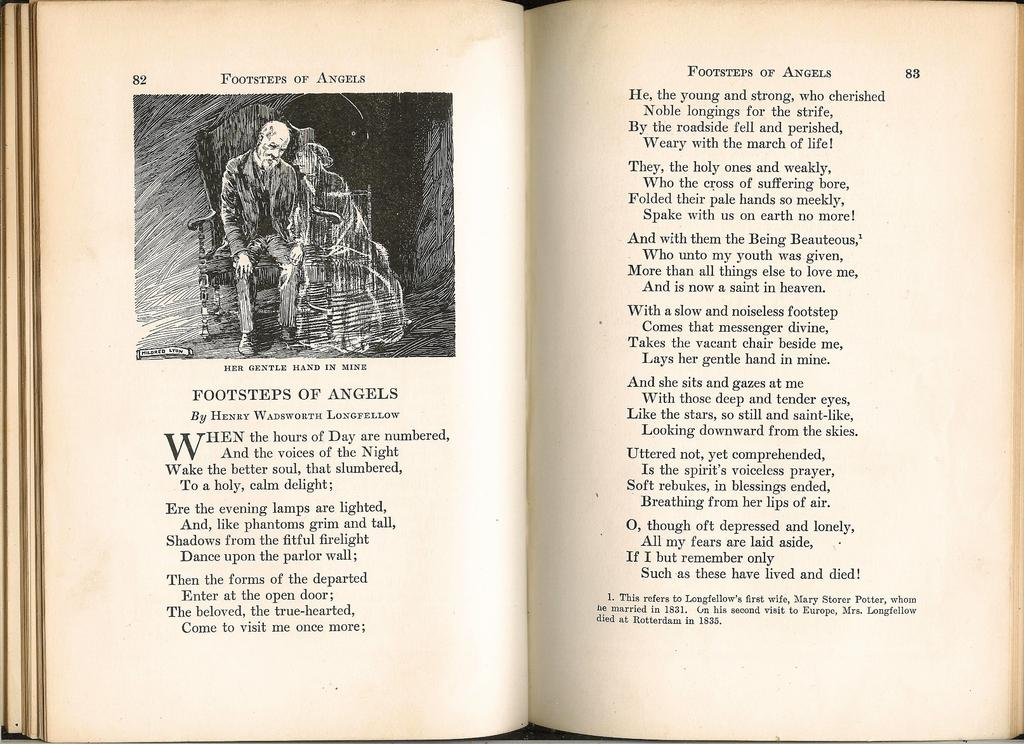Provide a one-sentence caption for the provided image. An older book features the poem "Footsteps of Angels" on page 82 with a lithograph drawing. 